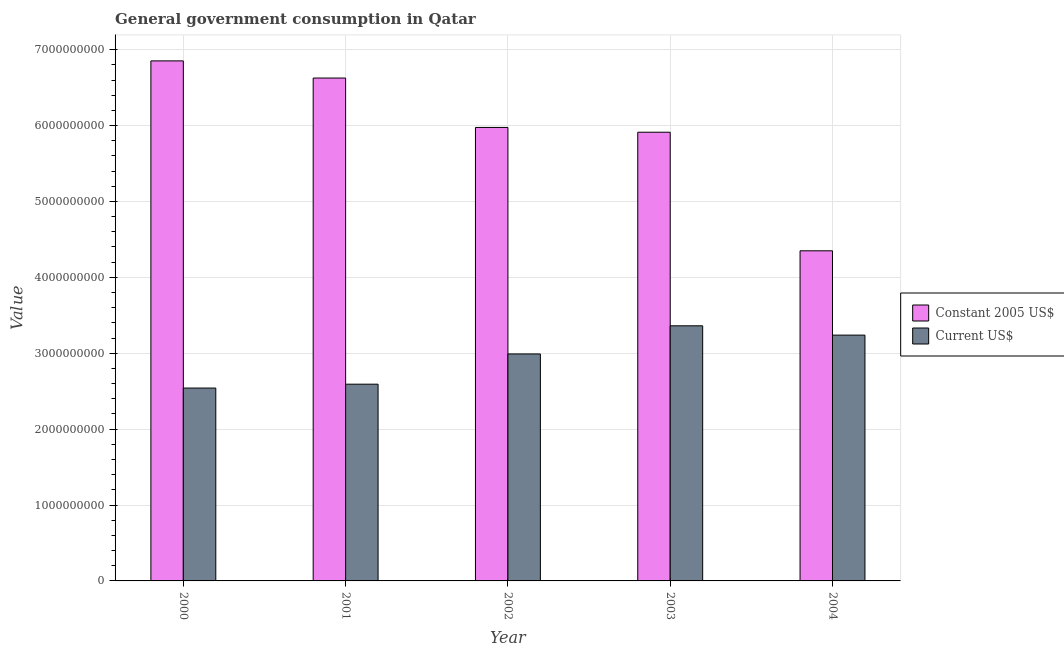How many groups of bars are there?
Offer a terse response. 5. Are the number of bars per tick equal to the number of legend labels?
Keep it short and to the point. Yes. Are the number of bars on each tick of the X-axis equal?
Offer a terse response. Yes. How many bars are there on the 2nd tick from the right?
Provide a succinct answer. 2. What is the value consumed in constant 2005 us$ in 2000?
Your response must be concise. 6.85e+09. Across all years, what is the maximum value consumed in constant 2005 us$?
Give a very brief answer. 6.85e+09. Across all years, what is the minimum value consumed in current us$?
Ensure brevity in your answer.  2.54e+09. In which year was the value consumed in constant 2005 us$ maximum?
Make the answer very short. 2000. In which year was the value consumed in constant 2005 us$ minimum?
Provide a succinct answer. 2004. What is the total value consumed in constant 2005 us$ in the graph?
Provide a succinct answer. 2.97e+1. What is the difference between the value consumed in current us$ in 2000 and that in 2002?
Offer a terse response. -4.49e+08. What is the difference between the value consumed in constant 2005 us$ in 2003 and the value consumed in current us$ in 2004?
Your answer should be compact. 1.56e+09. What is the average value consumed in current us$ per year?
Your response must be concise. 2.94e+09. In the year 2001, what is the difference between the value consumed in current us$ and value consumed in constant 2005 us$?
Offer a very short reply. 0. In how many years, is the value consumed in constant 2005 us$ greater than 3800000000?
Provide a succinct answer. 5. What is the ratio of the value consumed in current us$ in 2001 to that in 2003?
Give a very brief answer. 0.77. Is the value consumed in constant 2005 us$ in 2000 less than that in 2002?
Your response must be concise. No. Is the difference between the value consumed in constant 2005 us$ in 2001 and 2004 greater than the difference between the value consumed in current us$ in 2001 and 2004?
Keep it short and to the point. No. What is the difference between the highest and the second highest value consumed in current us$?
Offer a terse response. 1.23e+08. What is the difference between the highest and the lowest value consumed in constant 2005 us$?
Give a very brief answer. 2.50e+09. In how many years, is the value consumed in current us$ greater than the average value consumed in current us$ taken over all years?
Keep it short and to the point. 3. What does the 1st bar from the left in 2004 represents?
Make the answer very short. Constant 2005 US$. What does the 1st bar from the right in 2000 represents?
Your answer should be very brief. Current US$. How many bars are there?
Provide a short and direct response. 10. How many years are there in the graph?
Keep it short and to the point. 5. What is the difference between two consecutive major ticks on the Y-axis?
Offer a terse response. 1.00e+09. Does the graph contain any zero values?
Give a very brief answer. No. How are the legend labels stacked?
Ensure brevity in your answer.  Vertical. What is the title of the graph?
Your response must be concise. General government consumption in Qatar. Does "Netherlands" appear as one of the legend labels in the graph?
Provide a short and direct response. No. What is the label or title of the X-axis?
Keep it short and to the point. Year. What is the label or title of the Y-axis?
Provide a short and direct response. Value. What is the Value in Constant 2005 US$ in 2000?
Your answer should be very brief. 6.85e+09. What is the Value of Current US$ in 2000?
Your answer should be compact. 2.54e+09. What is the Value in Constant 2005 US$ in 2001?
Offer a very short reply. 6.63e+09. What is the Value of Current US$ in 2001?
Make the answer very short. 2.59e+09. What is the Value of Constant 2005 US$ in 2002?
Keep it short and to the point. 5.98e+09. What is the Value of Current US$ in 2002?
Keep it short and to the point. 2.99e+09. What is the Value in Constant 2005 US$ in 2003?
Give a very brief answer. 5.91e+09. What is the Value in Current US$ in 2003?
Make the answer very short. 3.36e+09. What is the Value of Constant 2005 US$ in 2004?
Keep it short and to the point. 4.35e+09. What is the Value in Current US$ in 2004?
Offer a terse response. 3.24e+09. Across all years, what is the maximum Value in Constant 2005 US$?
Offer a very short reply. 6.85e+09. Across all years, what is the maximum Value in Current US$?
Provide a succinct answer. 3.36e+09. Across all years, what is the minimum Value in Constant 2005 US$?
Provide a short and direct response. 4.35e+09. Across all years, what is the minimum Value in Current US$?
Your answer should be very brief. 2.54e+09. What is the total Value in Constant 2005 US$ in the graph?
Offer a terse response. 2.97e+1. What is the total Value in Current US$ in the graph?
Ensure brevity in your answer.  1.47e+1. What is the difference between the Value of Constant 2005 US$ in 2000 and that in 2001?
Offer a very short reply. 2.26e+08. What is the difference between the Value in Current US$ in 2000 and that in 2001?
Your answer should be compact. -5.11e+07. What is the difference between the Value in Constant 2005 US$ in 2000 and that in 2002?
Your response must be concise. 8.77e+08. What is the difference between the Value in Current US$ in 2000 and that in 2002?
Make the answer very short. -4.49e+08. What is the difference between the Value of Constant 2005 US$ in 2000 and that in 2003?
Offer a terse response. 9.40e+08. What is the difference between the Value in Current US$ in 2000 and that in 2003?
Ensure brevity in your answer.  -8.20e+08. What is the difference between the Value of Constant 2005 US$ in 2000 and that in 2004?
Your answer should be very brief. 2.50e+09. What is the difference between the Value of Current US$ in 2000 and that in 2004?
Your response must be concise. -6.98e+08. What is the difference between the Value of Constant 2005 US$ in 2001 and that in 2002?
Keep it short and to the point. 6.51e+08. What is the difference between the Value in Current US$ in 2001 and that in 2002?
Provide a short and direct response. -3.98e+08. What is the difference between the Value in Constant 2005 US$ in 2001 and that in 2003?
Provide a short and direct response. 7.14e+08. What is the difference between the Value of Current US$ in 2001 and that in 2003?
Offer a terse response. -7.69e+08. What is the difference between the Value in Constant 2005 US$ in 2001 and that in 2004?
Your answer should be compact. 2.28e+09. What is the difference between the Value of Current US$ in 2001 and that in 2004?
Ensure brevity in your answer.  -6.46e+08. What is the difference between the Value of Constant 2005 US$ in 2002 and that in 2003?
Offer a terse response. 6.29e+07. What is the difference between the Value in Current US$ in 2002 and that in 2003?
Ensure brevity in your answer.  -3.71e+08. What is the difference between the Value of Constant 2005 US$ in 2002 and that in 2004?
Offer a very short reply. 1.63e+09. What is the difference between the Value in Current US$ in 2002 and that in 2004?
Provide a short and direct response. -2.48e+08. What is the difference between the Value of Constant 2005 US$ in 2003 and that in 2004?
Keep it short and to the point. 1.56e+09. What is the difference between the Value in Current US$ in 2003 and that in 2004?
Make the answer very short. 1.23e+08. What is the difference between the Value in Constant 2005 US$ in 2000 and the Value in Current US$ in 2001?
Your answer should be compact. 4.26e+09. What is the difference between the Value of Constant 2005 US$ in 2000 and the Value of Current US$ in 2002?
Your response must be concise. 3.86e+09. What is the difference between the Value of Constant 2005 US$ in 2000 and the Value of Current US$ in 2003?
Your answer should be compact. 3.49e+09. What is the difference between the Value of Constant 2005 US$ in 2000 and the Value of Current US$ in 2004?
Make the answer very short. 3.61e+09. What is the difference between the Value in Constant 2005 US$ in 2001 and the Value in Current US$ in 2002?
Your answer should be very brief. 3.64e+09. What is the difference between the Value of Constant 2005 US$ in 2001 and the Value of Current US$ in 2003?
Your answer should be compact. 3.26e+09. What is the difference between the Value in Constant 2005 US$ in 2001 and the Value in Current US$ in 2004?
Give a very brief answer. 3.39e+09. What is the difference between the Value of Constant 2005 US$ in 2002 and the Value of Current US$ in 2003?
Offer a very short reply. 2.61e+09. What is the difference between the Value of Constant 2005 US$ in 2002 and the Value of Current US$ in 2004?
Your response must be concise. 2.74e+09. What is the difference between the Value of Constant 2005 US$ in 2003 and the Value of Current US$ in 2004?
Give a very brief answer. 2.67e+09. What is the average Value of Constant 2005 US$ per year?
Your answer should be compact. 5.94e+09. What is the average Value of Current US$ per year?
Give a very brief answer. 2.94e+09. In the year 2000, what is the difference between the Value in Constant 2005 US$ and Value in Current US$?
Keep it short and to the point. 4.31e+09. In the year 2001, what is the difference between the Value in Constant 2005 US$ and Value in Current US$?
Keep it short and to the point. 4.03e+09. In the year 2002, what is the difference between the Value of Constant 2005 US$ and Value of Current US$?
Make the answer very short. 2.98e+09. In the year 2003, what is the difference between the Value in Constant 2005 US$ and Value in Current US$?
Ensure brevity in your answer.  2.55e+09. In the year 2004, what is the difference between the Value in Constant 2005 US$ and Value in Current US$?
Your answer should be compact. 1.11e+09. What is the ratio of the Value of Constant 2005 US$ in 2000 to that in 2001?
Offer a very short reply. 1.03. What is the ratio of the Value in Current US$ in 2000 to that in 2001?
Your answer should be very brief. 0.98. What is the ratio of the Value in Constant 2005 US$ in 2000 to that in 2002?
Provide a succinct answer. 1.15. What is the ratio of the Value of Current US$ in 2000 to that in 2002?
Give a very brief answer. 0.85. What is the ratio of the Value of Constant 2005 US$ in 2000 to that in 2003?
Keep it short and to the point. 1.16. What is the ratio of the Value of Current US$ in 2000 to that in 2003?
Provide a short and direct response. 0.76. What is the ratio of the Value of Constant 2005 US$ in 2000 to that in 2004?
Provide a short and direct response. 1.58. What is the ratio of the Value in Current US$ in 2000 to that in 2004?
Provide a short and direct response. 0.78. What is the ratio of the Value of Constant 2005 US$ in 2001 to that in 2002?
Give a very brief answer. 1.11. What is the ratio of the Value of Current US$ in 2001 to that in 2002?
Provide a succinct answer. 0.87. What is the ratio of the Value in Constant 2005 US$ in 2001 to that in 2003?
Your response must be concise. 1.12. What is the ratio of the Value of Current US$ in 2001 to that in 2003?
Make the answer very short. 0.77. What is the ratio of the Value of Constant 2005 US$ in 2001 to that in 2004?
Provide a succinct answer. 1.52. What is the ratio of the Value in Current US$ in 2001 to that in 2004?
Your answer should be compact. 0.8. What is the ratio of the Value in Constant 2005 US$ in 2002 to that in 2003?
Your answer should be very brief. 1.01. What is the ratio of the Value of Current US$ in 2002 to that in 2003?
Your answer should be very brief. 0.89. What is the ratio of the Value in Constant 2005 US$ in 2002 to that in 2004?
Make the answer very short. 1.37. What is the ratio of the Value in Current US$ in 2002 to that in 2004?
Your answer should be very brief. 0.92. What is the ratio of the Value in Constant 2005 US$ in 2003 to that in 2004?
Your answer should be very brief. 1.36. What is the ratio of the Value of Current US$ in 2003 to that in 2004?
Your answer should be compact. 1.04. What is the difference between the highest and the second highest Value in Constant 2005 US$?
Keep it short and to the point. 2.26e+08. What is the difference between the highest and the second highest Value of Current US$?
Provide a short and direct response. 1.23e+08. What is the difference between the highest and the lowest Value in Constant 2005 US$?
Provide a short and direct response. 2.50e+09. What is the difference between the highest and the lowest Value in Current US$?
Your response must be concise. 8.20e+08. 